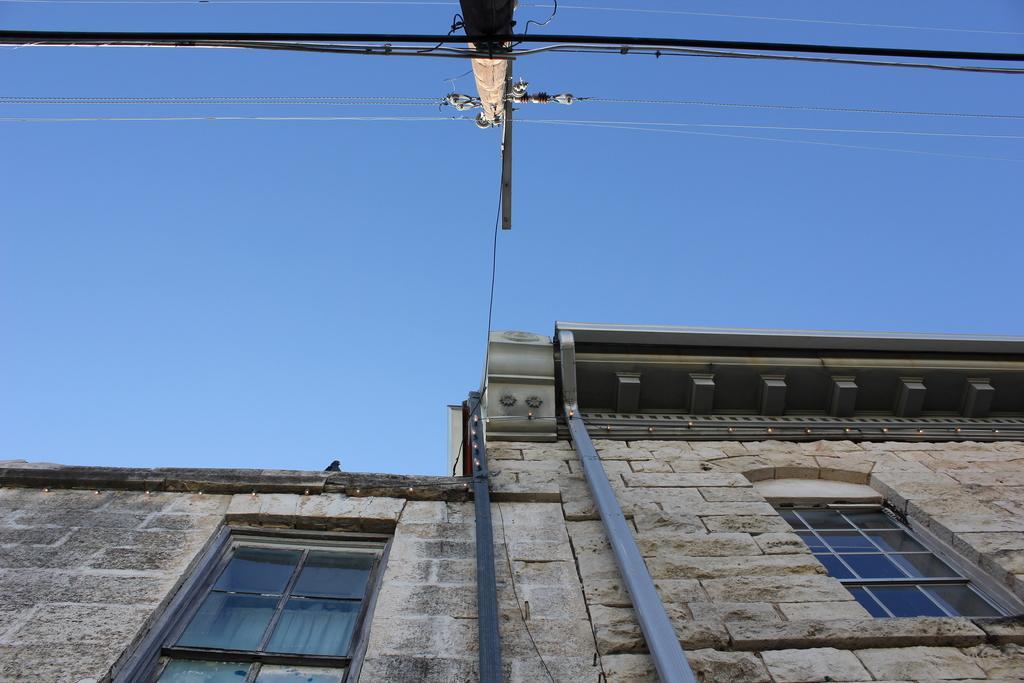Describe this image in one or two sentences. This picture might be taken from outside of the building. In this image, we can see a building, glass window. At the top, we can see a electric pole, electric wires. In the background, we can see a sky. 